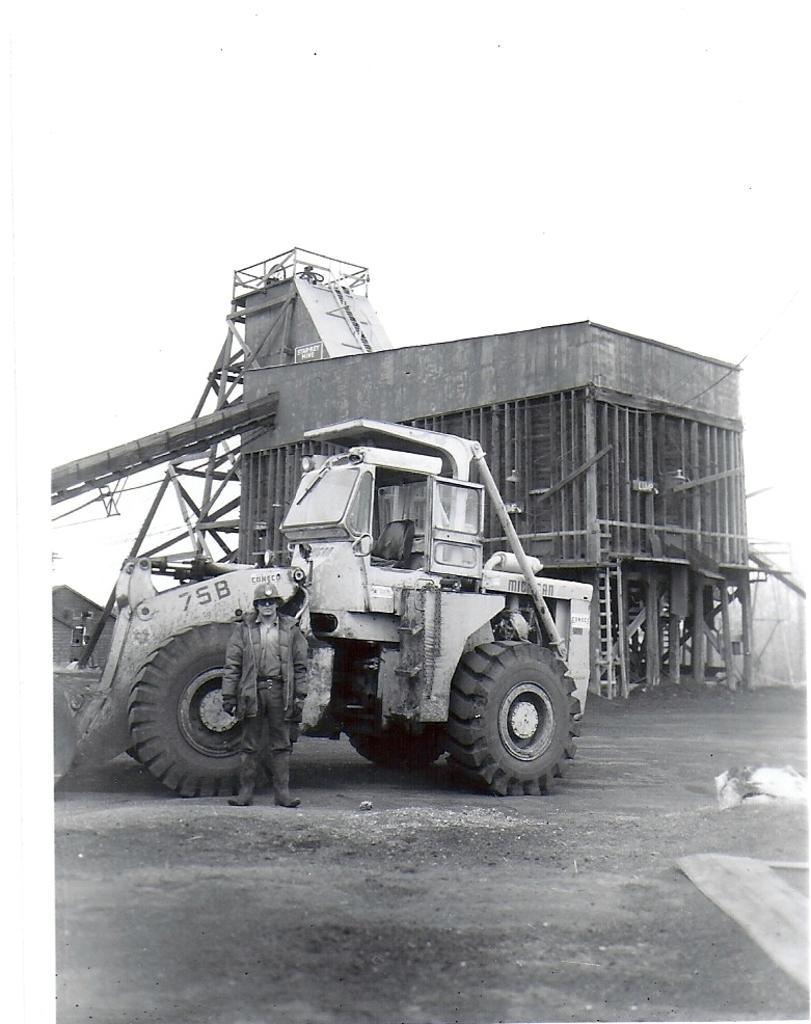In one or two sentences, can you explain what this image depicts? This picture is clicked outside. In the center we can see a person wearing jacket and standing on the ground and we can see a tractor seems to be parked on the ground. In the background we can see the sky, a cabin and some other objects. 